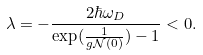Convert formula to latex. <formula><loc_0><loc_0><loc_500><loc_500>\lambda = - \frac { 2 \hbar { \omega } _ { D } } { \exp ( \frac { 1 } { g \mathcal { N } ( 0 ) } ) - 1 } < 0 .</formula> 